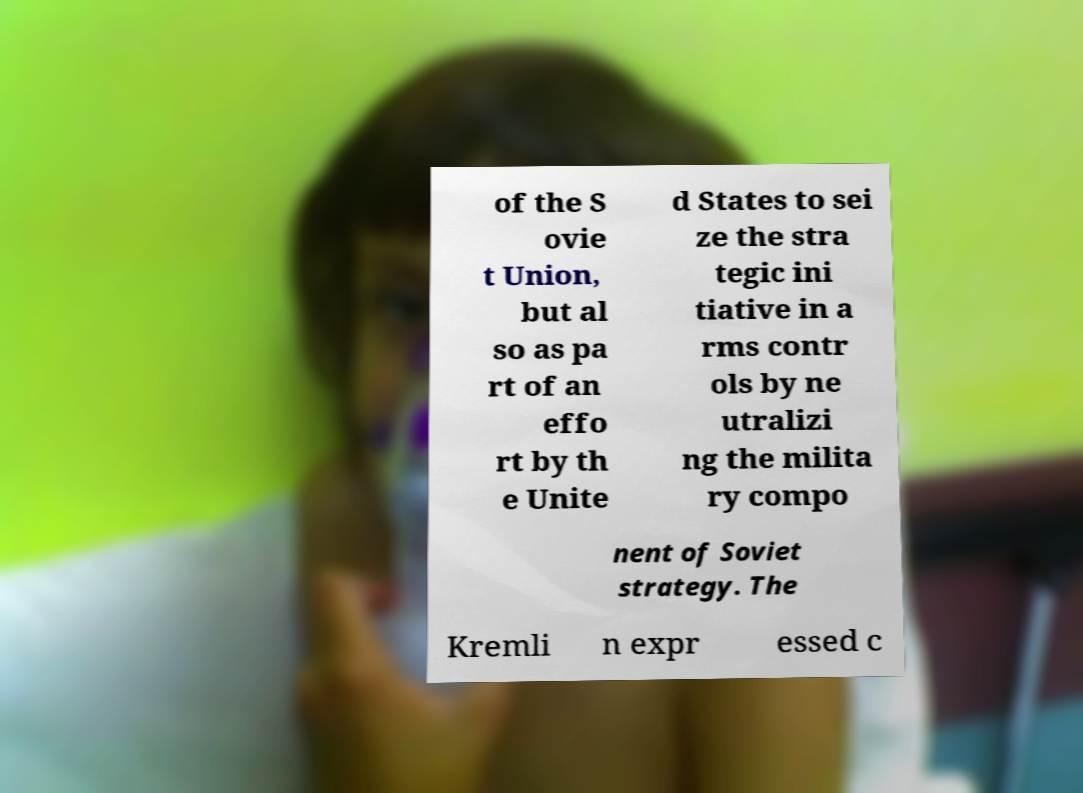Could you extract and type out the text from this image? of the S ovie t Union, but al so as pa rt of an effo rt by th e Unite d States to sei ze the stra tegic ini tiative in a rms contr ols by ne utralizi ng the milita ry compo nent of Soviet strategy. The Kremli n expr essed c 